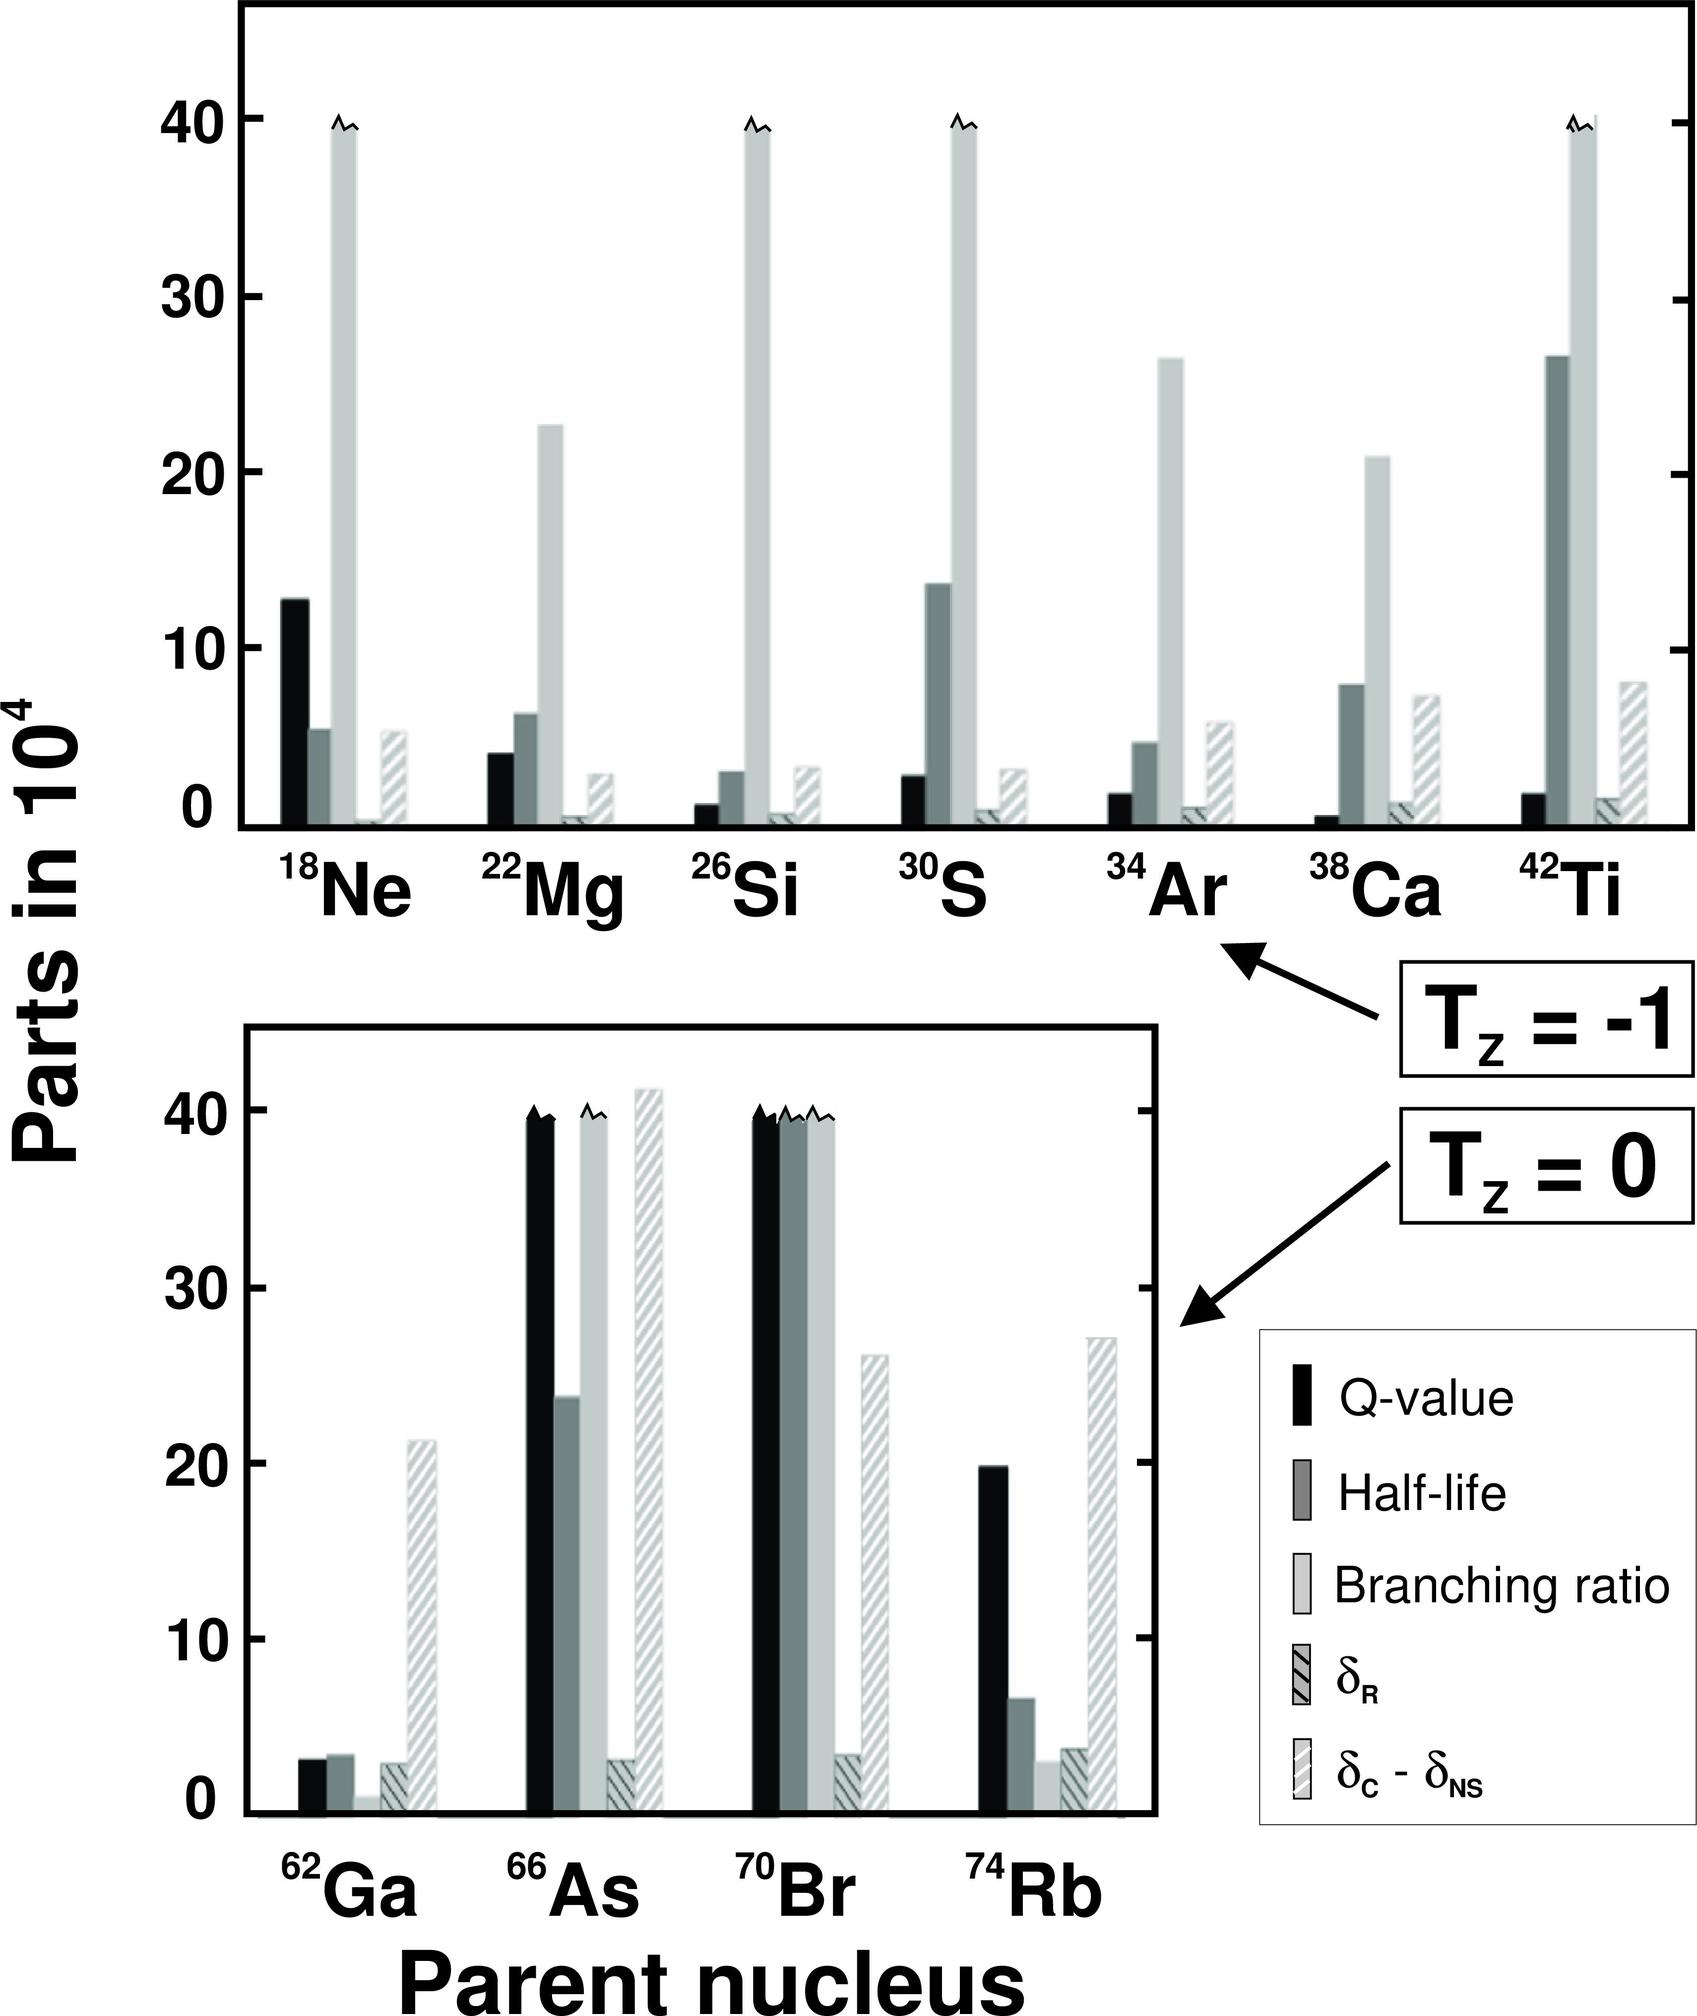Can you explain the significance of the T_z = -1 and T_z = 0 labels on the graph? Certainly, the labels T_z = -1 and T_z = 0 refer to the isospin projection of the nuclei, which is related to the difference between the number of protons and neutrons in a nucleus. T_z = -1 indicates nuclei with one more proton than neutrons, which generally undergo beta-plus decay or electron capture to become more stable. T_z = 0 denotes nuclei where the number of protons and neutrons are equal, leading to a more stable configuration. In nuclear physics, isospin projection is an important quantum number for classifying nuclei, especially when studying nuclear reactions and decay processes.  Given that these are all beta-plus decay candidates, what does a higher Q-value imply for the decay process? A higher Q-value in beta-plus decay suggests that there is a greater amount of energy released when the nucleus decays. This increase in energy release enables the decay process to occur more readily, as it indicates the decay leads to a significantly more stable state for the daughter nucleus. Intuitively, the higher Q-value for a decay reaction means that the transition is energetically more favorable, and it may also influence the decay rate, leading potentially to shorter half-lives for the decay process. 